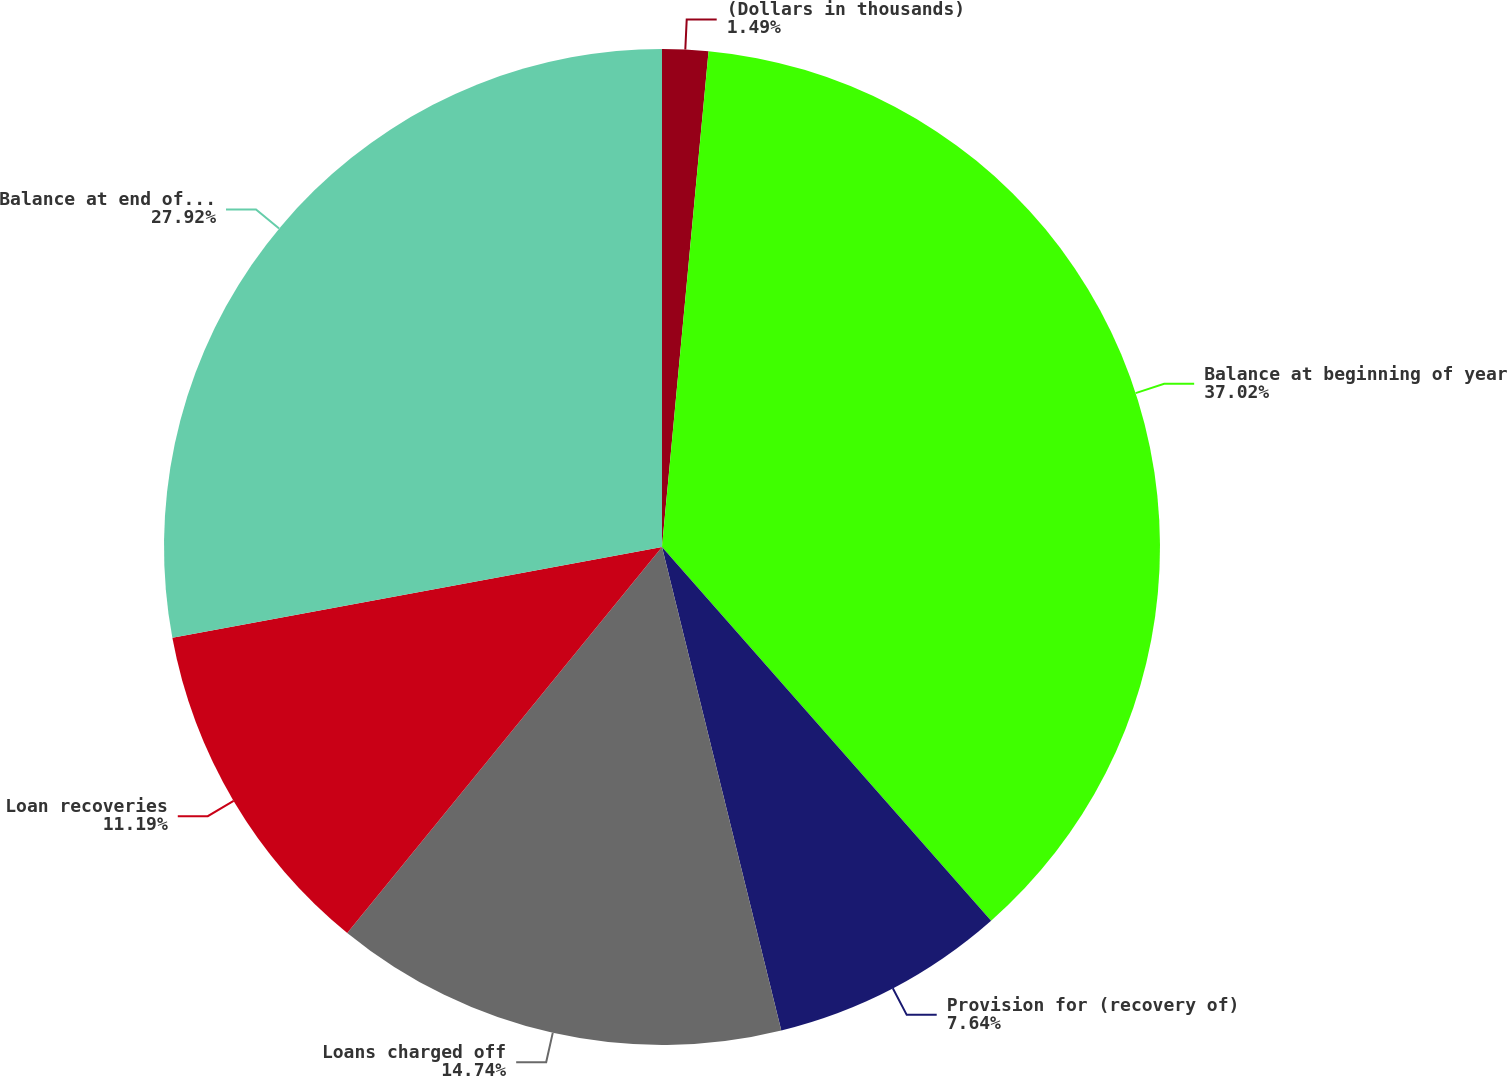Convert chart to OTSL. <chart><loc_0><loc_0><loc_500><loc_500><pie_chart><fcel>(Dollars in thousands)<fcel>Balance at beginning of year<fcel>Provision for (recovery of)<fcel>Loans charged off<fcel>Loan recoveries<fcel>Balance at end of year<nl><fcel>1.49%<fcel>37.02%<fcel>7.64%<fcel>14.74%<fcel>11.19%<fcel>27.92%<nl></chart> 